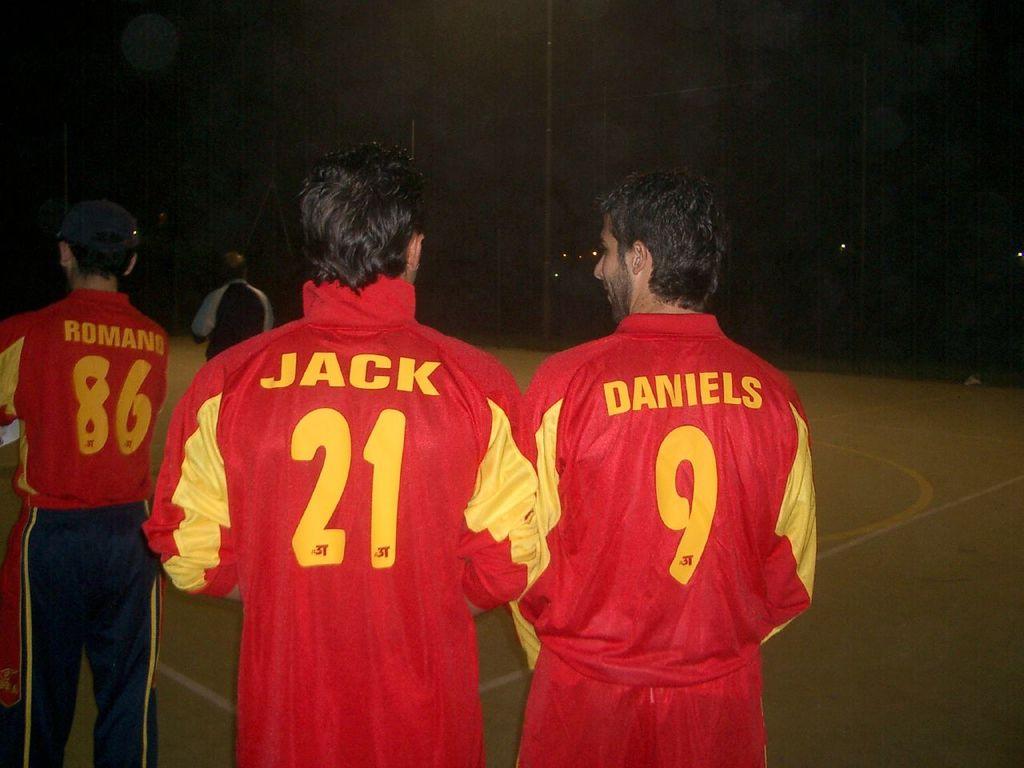What's the player's number that's standing by himself?
Your answer should be very brief. 86. Ju are the initials?
Give a very brief answer. No. 